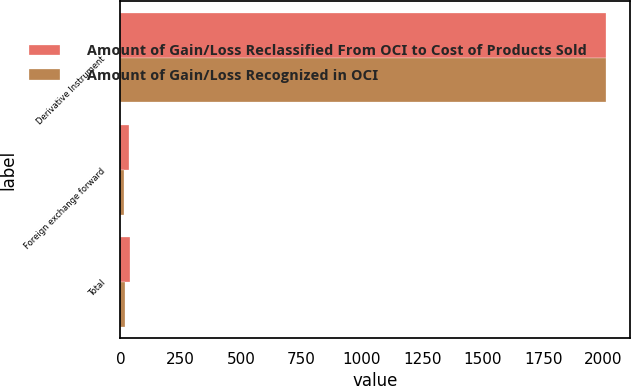<chart> <loc_0><loc_0><loc_500><loc_500><stacked_bar_chart><ecel><fcel>Derivative Instrument<fcel>Foreign exchange forward<fcel>Total<nl><fcel>Amount of Gain/Loss Reclassified From OCI to Cost of Products Sold<fcel>2009<fcel>35.8<fcel>37.8<nl><fcel>Amount of Gain/Loss Recognized in OCI<fcel>2009<fcel>16.8<fcel>18<nl></chart> 